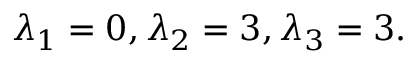<formula> <loc_0><loc_0><loc_500><loc_500>\lambda _ { 1 } = 0 , \lambda _ { 2 } = 3 , \lambda _ { 3 } = 3 .</formula> 